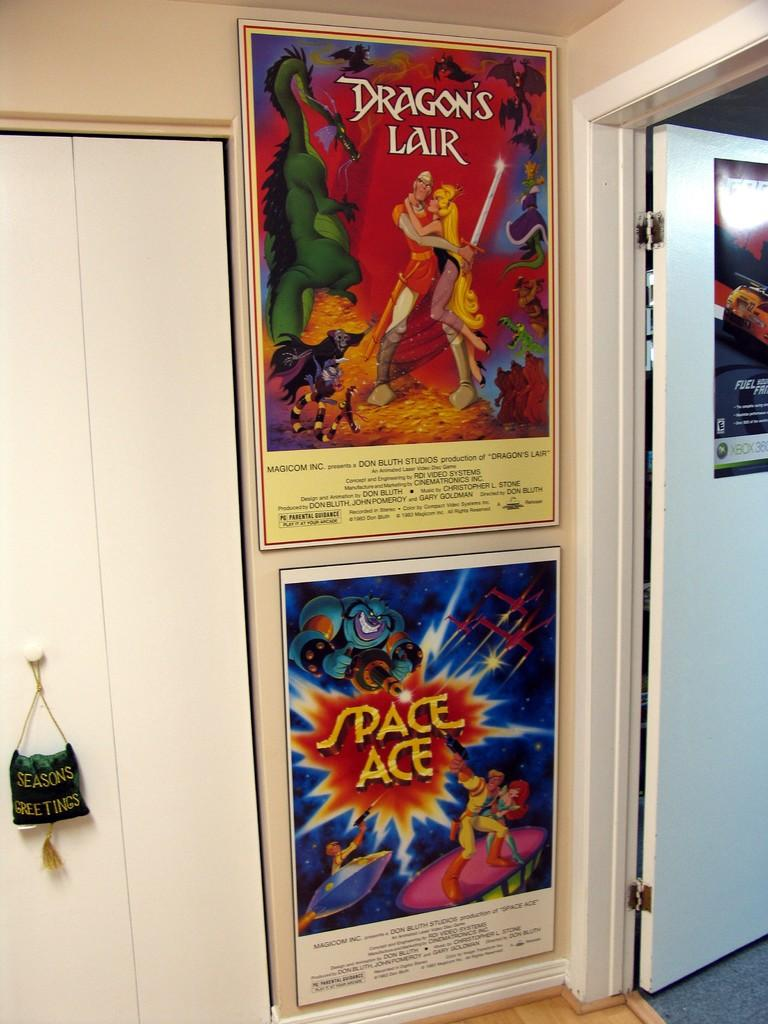What is on the wall in the room? There are two big posters on the wall in the room. Where is the door located in the room? The door is on the right side of the room. What is the door's function in the room? The door opens into another room. What type of chalk is being used to draw on the posters in the room? There is no chalk or drawing present on the posters in the image. Is there a horse in the room? No, there is no horse present in the image. 